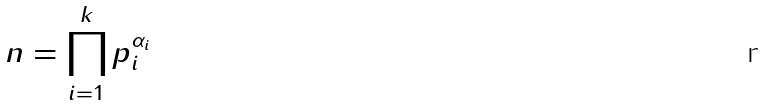<formula> <loc_0><loc_0><loc_500><loc_500>n = \prod _ { i = 1 } ^ { k } p _ { i } ^ { \alpha _ { i } }</formula> 